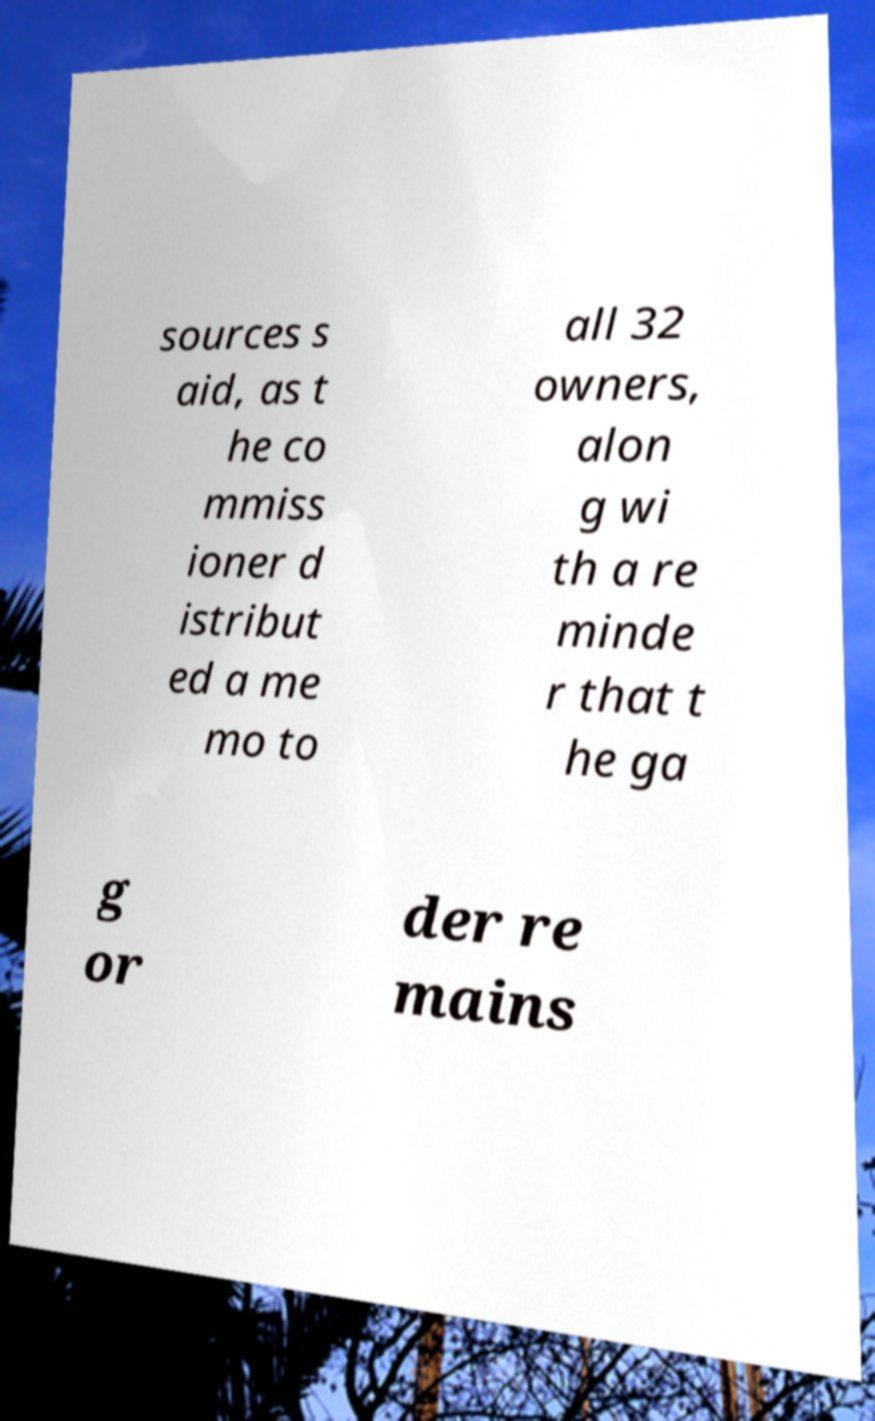Can you read and provide the text displayed in the image?This photo seems to have some interesting text. Can you extract and type it out for me? sources s aid, as t he co mmiss ioner d istribut ed a me mo to all 32 owners, alon g wi th a re minde r that t he ga g or der re mains 